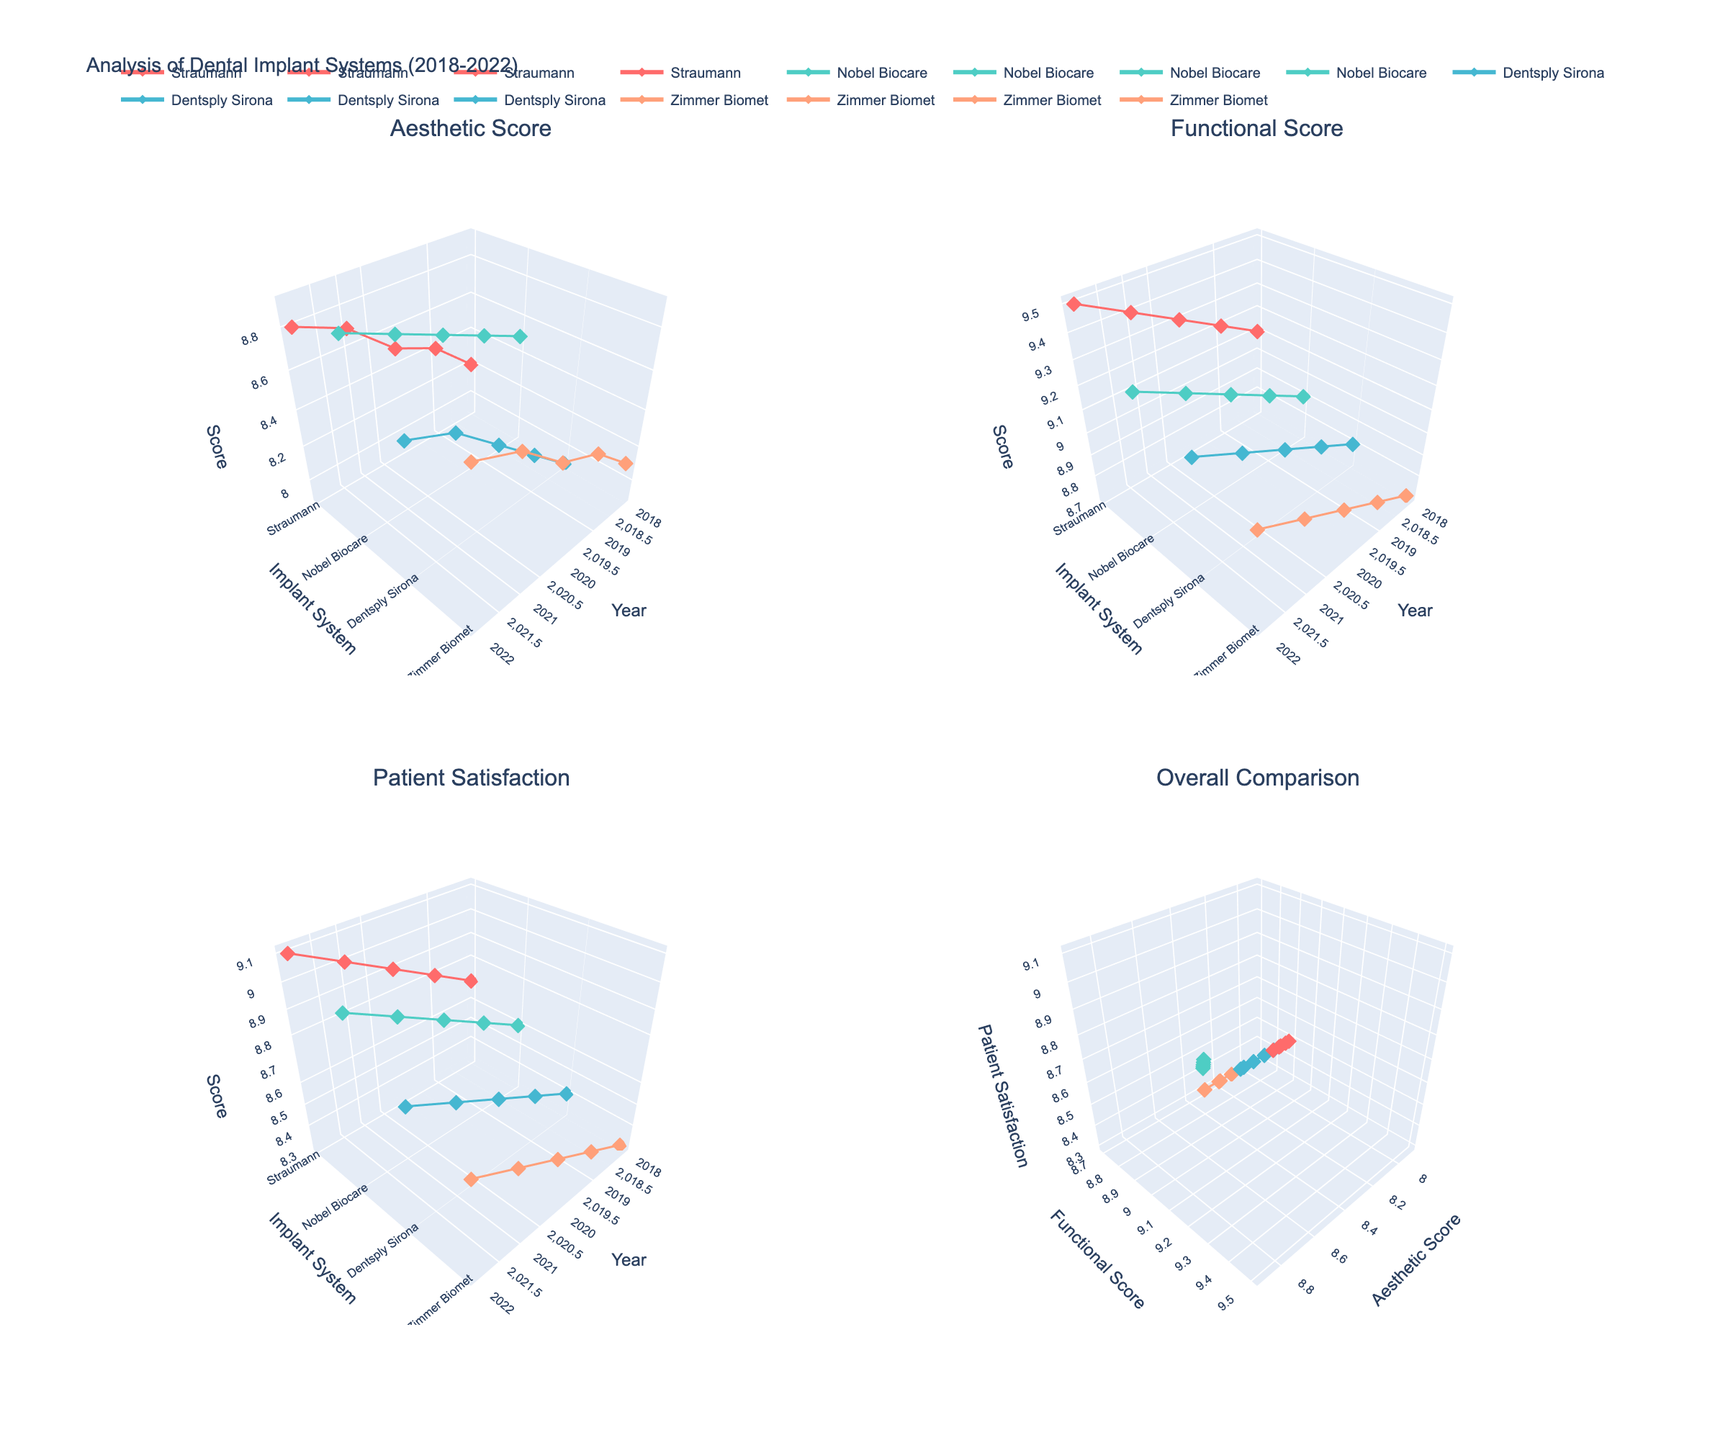What's the title of the figure? The title of the figure is displayed at the top of the plot and summarizes what the figure represents.
Answer: "Analysis of Dental Implant Systems (2018-2022)" How many different implant systems are presented in the figure? From the legend and axis labels, there are 4 unique implant systems represented, namely Straumann, Nobel Biocare, Dentsply Sirona, and Zimmer Biomet.
Answer: 4 What color represents the "Straumann" implant system? By looking at the legend that matches colors to implant systems, the "Straumann" implant system is represented by the color associated with its label.
Answer: #FF6B6B (Red) Which implant system had the highest aesthetic score in 2022? To find this, look specifically at the 'Aesthetic Score' subplot for the year 2022 and compare the scores for all implant systems. Nobel Biocare has the highest aesthetic score.
Answer: Nobel Biocare Did patient satisfaction for "Zimmer Biomet" consistently improve each year from 2018 to 2022? To determine this, observe the trend in the 'Patient Satisfaction' subplot for "Zimmer Biomet" over the years and check if the values consistently increased.
Answer: No, it did not consistently improve Which implant system had the highest functional score in 2019? In the 'Functional Score' subplot, examining the 2019 data points shows that Straumann has the highest functional score.
Answer: Straumann Between 2018 and 2022, which implant system exhibited the greatest improvement in patient satisfaction? The improvement is calculated by subtracting the 2018 satisfaction score from the 2022 score for each implant system. The implant system with the highest positive difference is Straumann (9.1 - 8.7 = 0.4).
Answer: Straumann Compare the patient satisfaction scores of "Dentsply Sirona" and "Zimmer Biomet" in 2021. Which is higher? In the 'Patient Satisfaction' subplot, compare the 2021 scores of "Dentsply Sirona" (8.7) and "Zimmer Biomet" (8.6).
Answer: Dentsply Sirona In the 'Overall Comparison' subplot, which implant system shows a close correlation between aesthetic and functional scores? In the 'Overall Comparison' subplot, identifying which data points form a close trend or alignment can show a correlation. Both Straumann and Nobel Biocare show close correlations.
Answer: Straumann and Nobel Biocare 